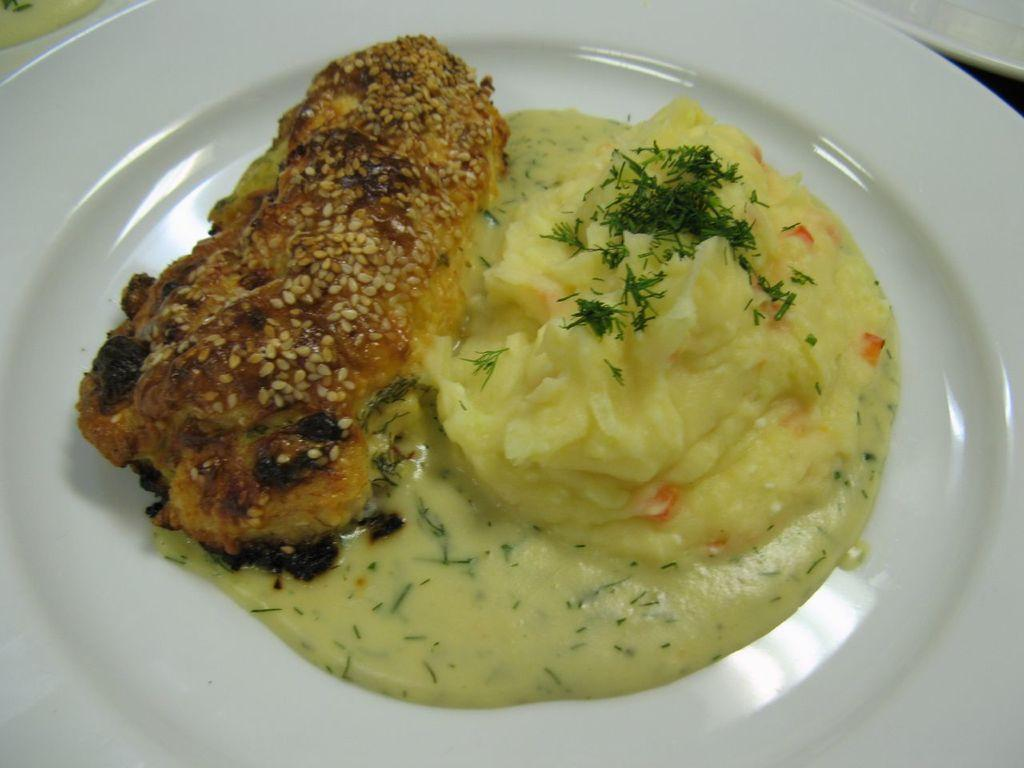What is on the plate that is visible in the image? There is food on the plate in the image. What color is the plate? The plate is white. Where is the basin located in the image? There is no basin present in the image. Who is the representative in the image? There is no representative present in the image. What type of haircut is visible on the person in the image? There is no person present in the image, so it is not possible to determine their haircut. 